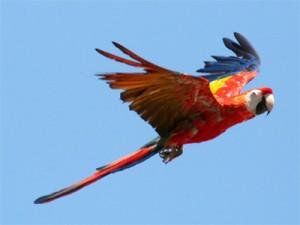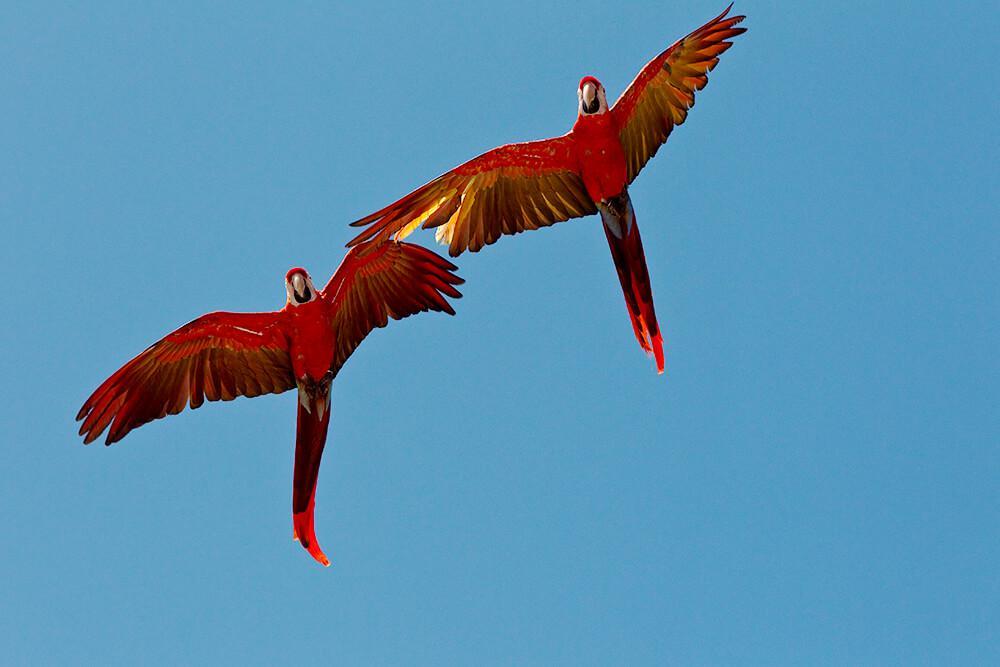The first image is the image on the left, the second image is the image on the right. For the images shown, is this caption "3 parrots are in flight in the image pair" true? Answer yes or no. Yes. The first image is the image on the left, the second image is the image on the right. Assess this claim about the two images: "There is one lone bird flying in one image and two birds flying together in the second.". Correct or not? Answer yes or no. Yes. 